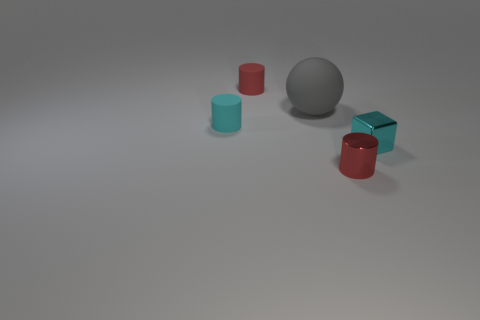The red object that is the same material as the big ball is what size?
Your response must be concise. Small. What material is the cyan cube?
Ensure brevity in your answer.  Metal. How many gray objects are the same size as the ball?
Provide a short and direct response. 0. The tiny matte object that is the same color as the small metallic cylinder is what shape?
Provide a succinct answer. Cylinder. Is there another rubber thing that has the same shape as the large object?
Provide a short and direct response. No. What is the color of the shiny cylinder that is the same size as the cube?
Your answer should be compact. Red. There is a big sphere that is left of the tiny shiny object on the right side of the metal cylinder; what is its color?
Give a very brief answer. Gray. There is a thing in front of the tiny shiny cube; does it have the same color as the large ball?
Offer a terse response. No. What shape is the red thing behind the red object in front of the tiny cyan thing left of the small cyan metal thing?
Your answer should be compact. Cylinder. How many red metallic objects are to the right of the small red object in front of the metallic block?
Your response must be concise. 0. 